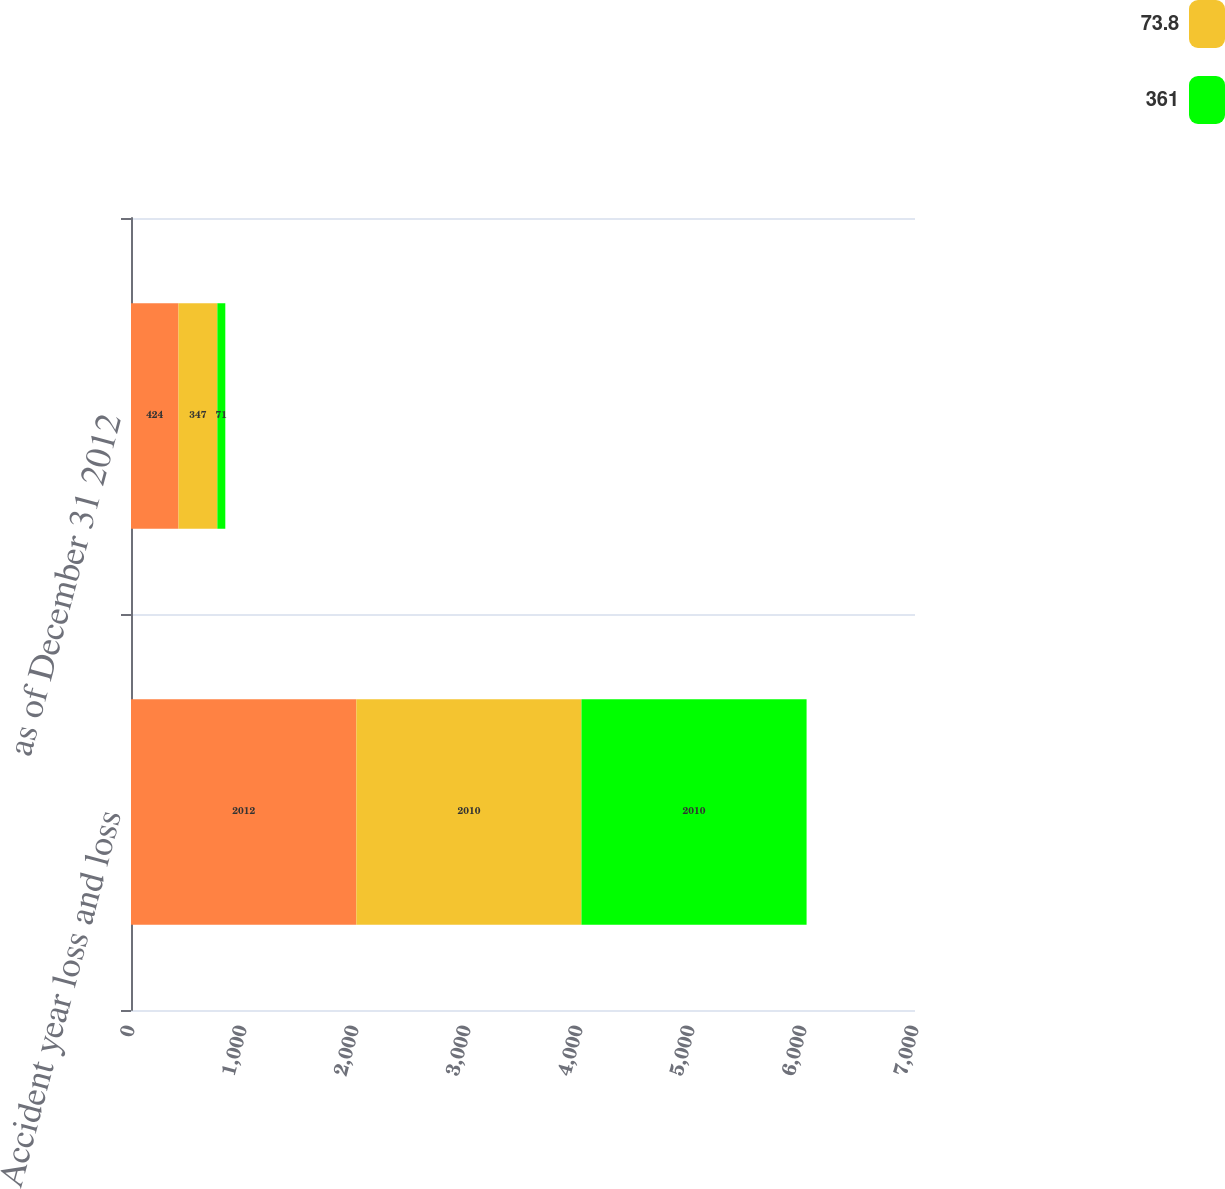Convert chart to OTSL. <chart><loc_0><loc_0><loc_500><loc_500><stacked_bar_chart><ecel><fcel>Accident year loss and loss<fcel>as of December 31 2012<nl><fcel>nan<fcel>2012<fcel>424<nl><fcel>73.8<fcel>2010<fcel>347<nl><fcel>361<fcel>2010<fcel>71<nl></chart> 